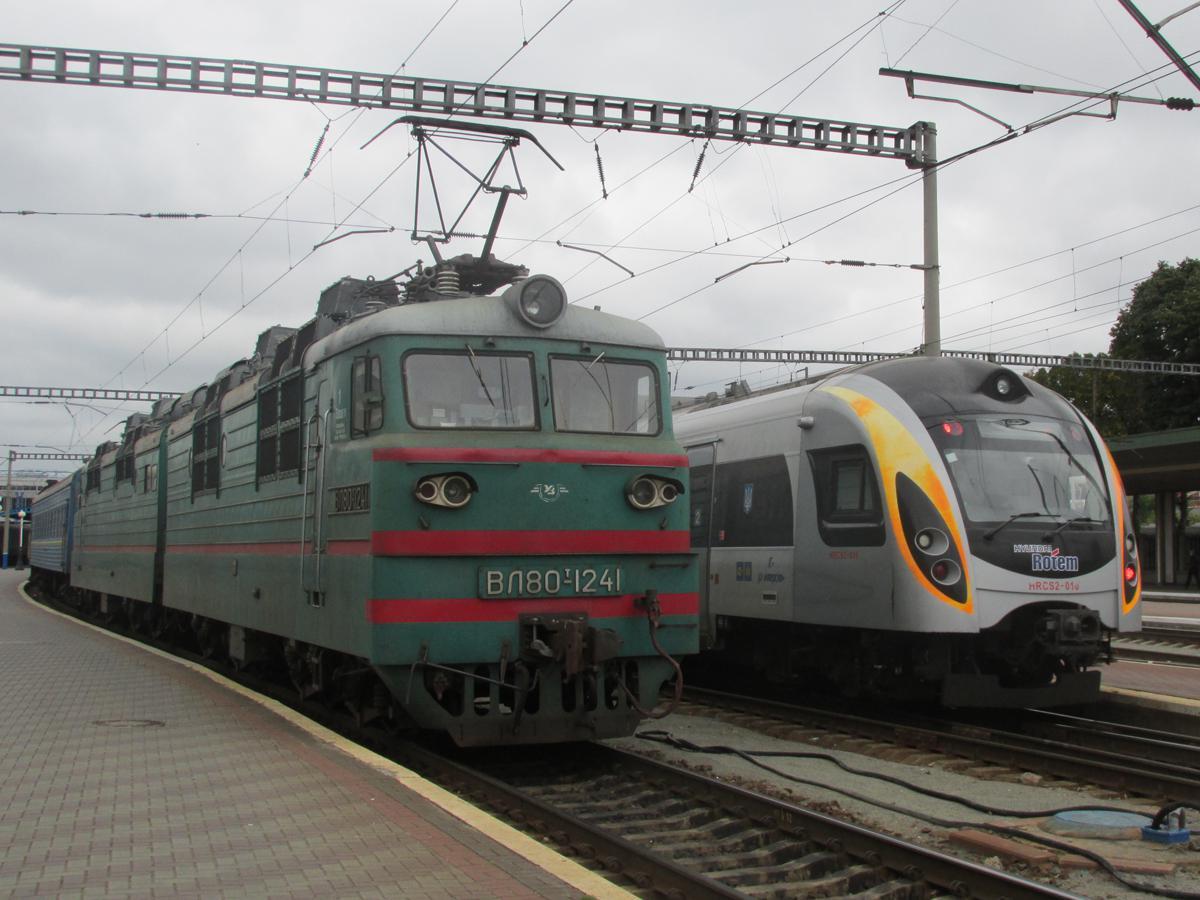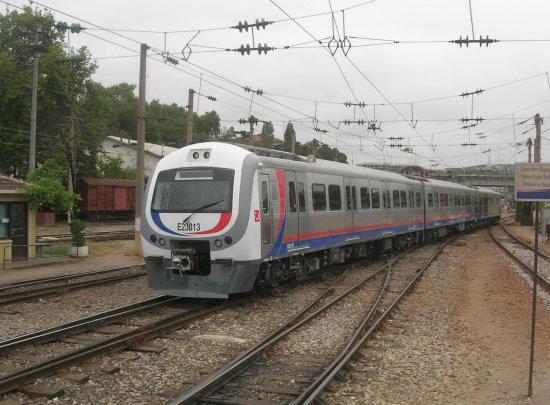The first image is the image on the left, the second image is the image on the right. For the images shown, is this caption "Both images have trains facing towards the right." true? Answer yes or no. No. The first image is the image on the left, the second image is the image on the right. Analyze the images presented: Is the assertion "One train contains the three colors red, white, and blue on the main body." valid? Answer yes or no. Yes. 